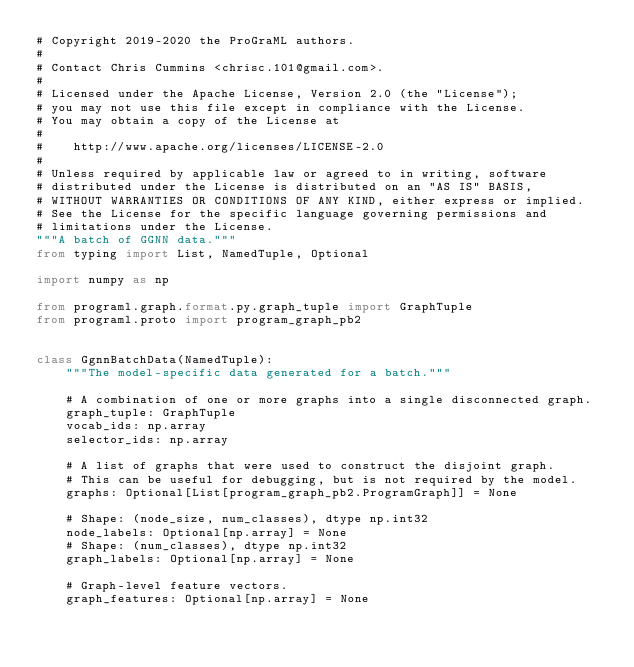Convert code to text. <code><loc_0><loc_0><loc_500><loc_500><_Python_># Copyright 2019-2020 the ProGraML authors.
#
# Contact Chris Cummins <chrisc.101@gmail.com>.
#
# Licensed under the Apache License, Version 2.0 (the "License");
# you may not use this file except in compliance with the License.
# You may obtain a copy of the License at
#
#    http://www.apache.org/licenses/LICENSE-2.0
#
# Unless required by applicable law or agreed to in writing, software
# distributed under the License is distributed on an "AS IS" BASIS,
# WITHOUT WARRANTIES OR CONDITIONS OF ANY KIND, either express or implied.
# See the License for the specific language governing permissions and
# limitations under the License.
"""A batch of GGNN data."""
from typing import List, NamedTuple, Optional

import numpy as np

from programl.graph.format.py.graph_tuple import GraphTuple
from programl.proto import program_graph_pb2


class GgnnBatchData(NamedTuple):
    """The model-specific data generated for a batch."""

    # A combination of one or more graphs into a single disconnected graph.
    graph_tuple: GraphTuple
    vocab_ids: np.array
    selector_ids: np.array

    # A list of graphs that were used to construct the disjoint graph.
    # This can be useful for debugging, but is not required by the model.
    graphs: Optional[List[program_graph_pb2.ProgramGraph]] = None

    # Shape: (node_size, num_classes), dtype np.int32
    node_labels: Optional[np.array] = None
    # Shape: (num_classes), dtype np.int32
    graph_labels: Optional[np.array] = None

    # Graph-level feature vectors.
    graph_features: Optional[np.array] = None
</code> 